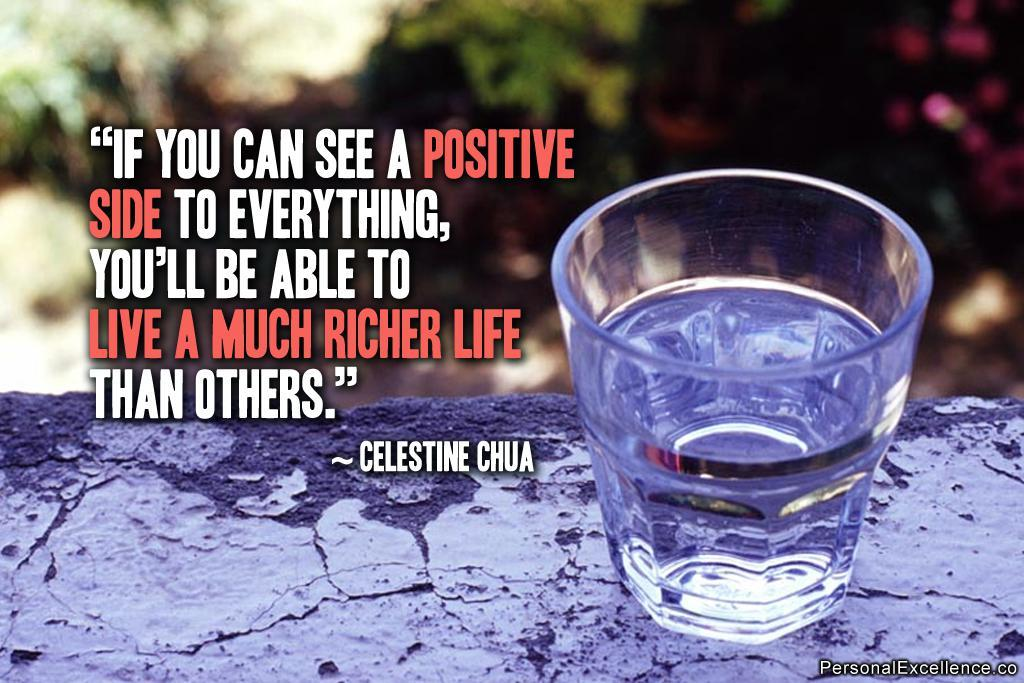<image>
Summarize the visual content of the image. a glass of water on a ledge next to a quotation by celestine chua 